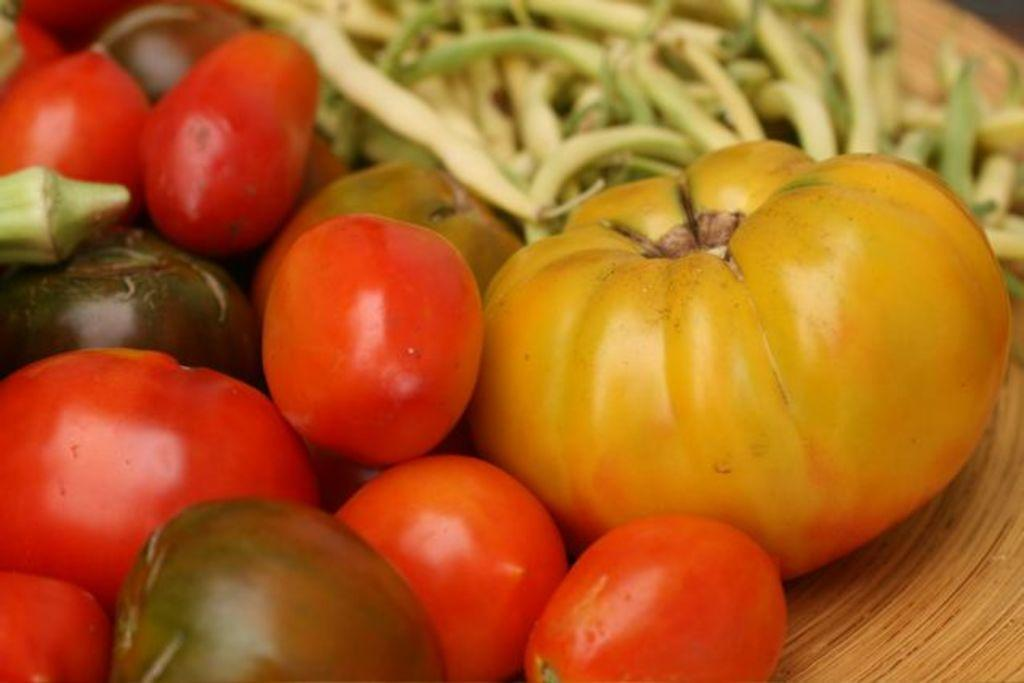What type of food items can be seen in the image? There are tomatoes and beans in the image, along with other vegetables. Where are the vegetables located in the image? The vegetables are on a table. Can you describe the other vegetables present in the image? Unfortunately, the provided facts do not specify which other vegetables are present in the image. What type of government is depicted in the image? There is no government depicted in the image; it features vegetables on a table. What experience can be gained from observing the vegetables in the image? There is no experience to be gained from observing the vegetables in the image; it is simply a still image of vegetables on a table. 